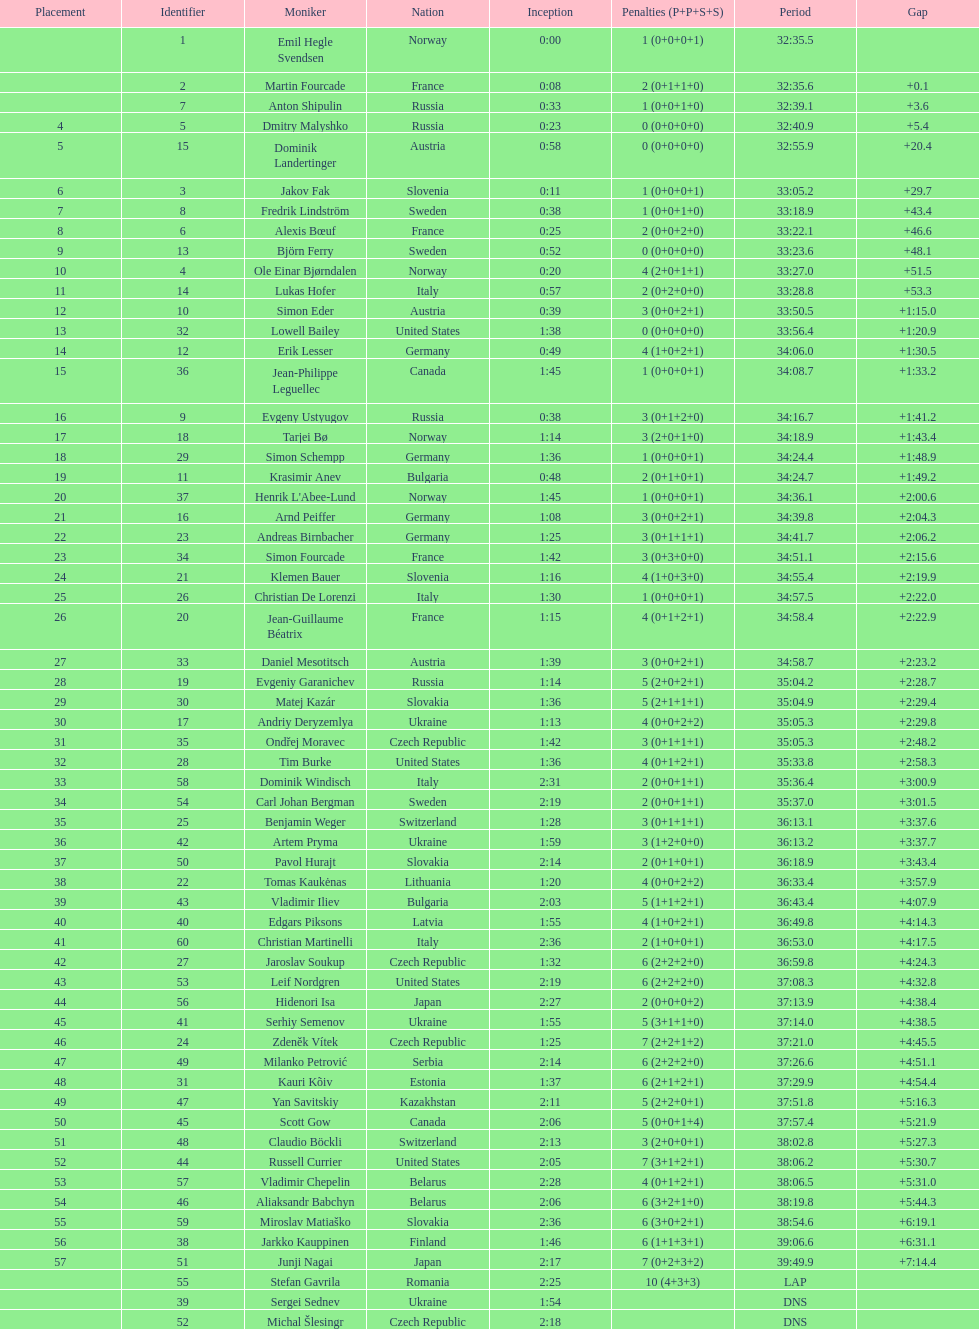How long did it take for erik lesser to finish? 34:06.0. 